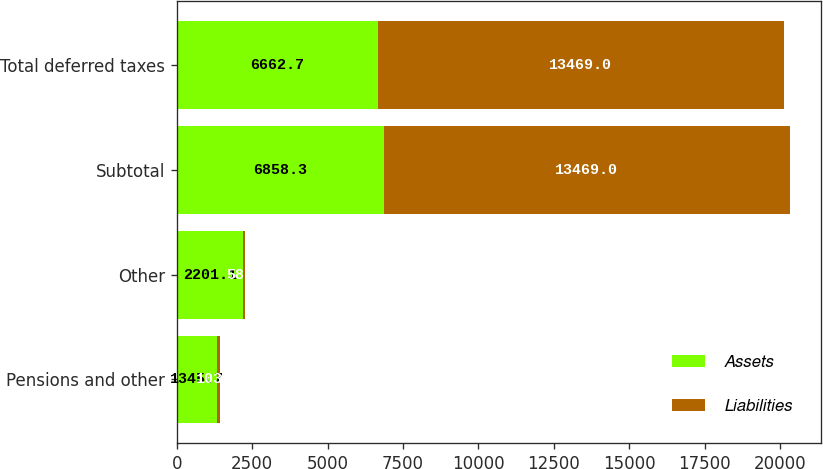Convert chart to OTSL. <chart><loc_0><loc_0><loc_500><loc_500><stacked_bar_chart><ecel><fcel>Pensions and other<fcel>Other<fcel>Subtotal<fcel>Total deferred taxes<nl><fcel>Assets<fcel>1345.7<fcel>2201.1<fcel>6858.3<fcel>6662.7<nl><fcel>Liabilities<fcel>103.1<fcel>58.4<fcel>13469<fcel>13469<nl></chart> 